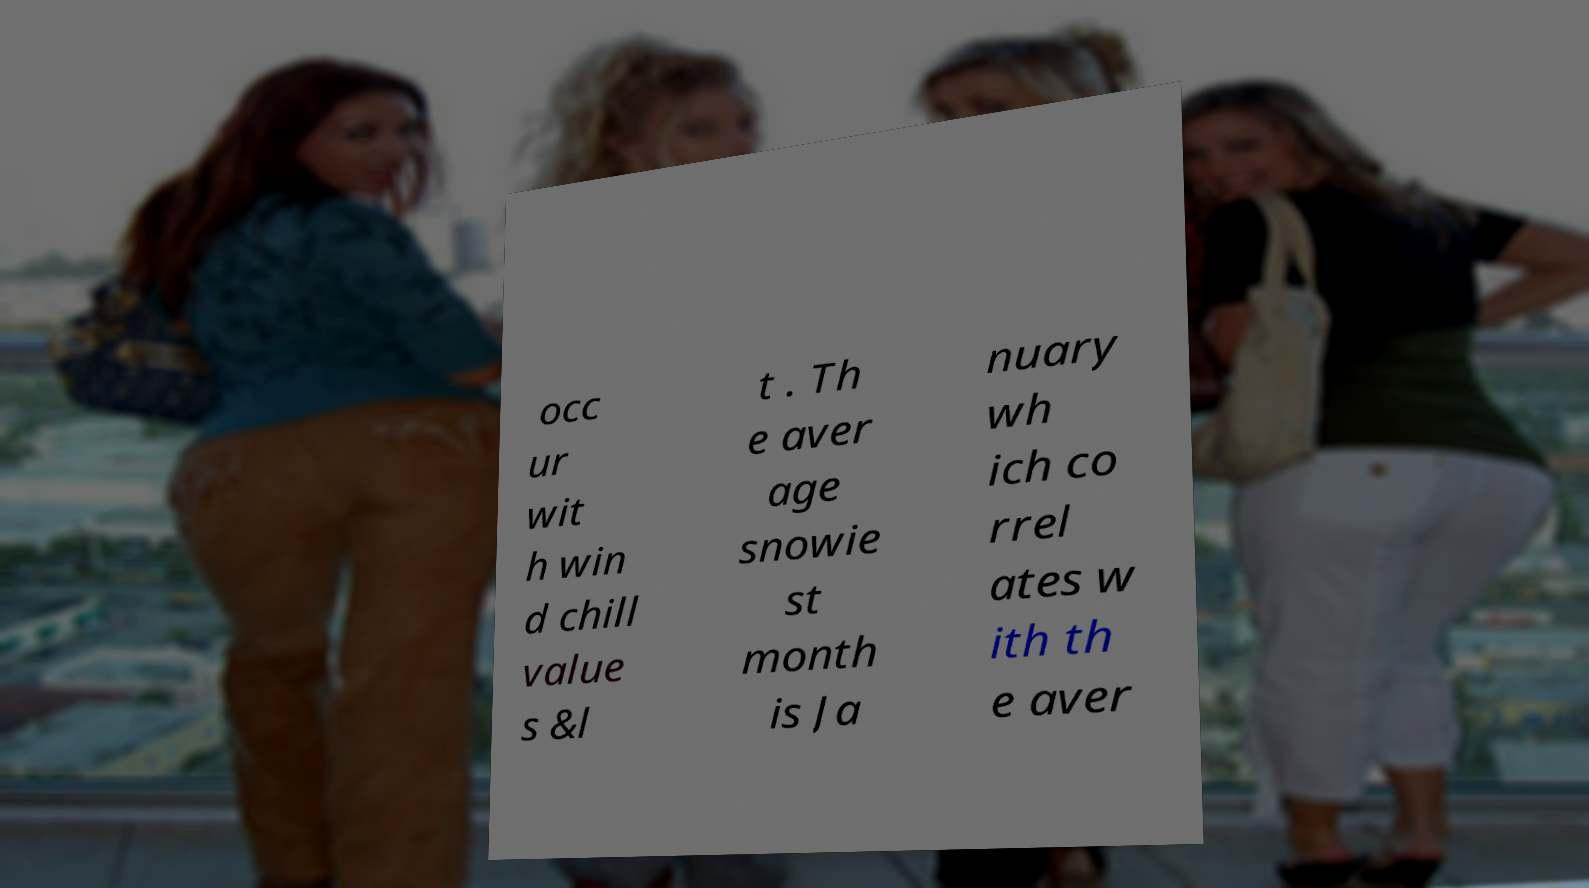Can you accurately transcribe the text from the provided image for me? occ ur wit h win d chill value s &l t . Th e aver age snowie st month is Ja nuary wh ich co rrel ates w ith th e aver 